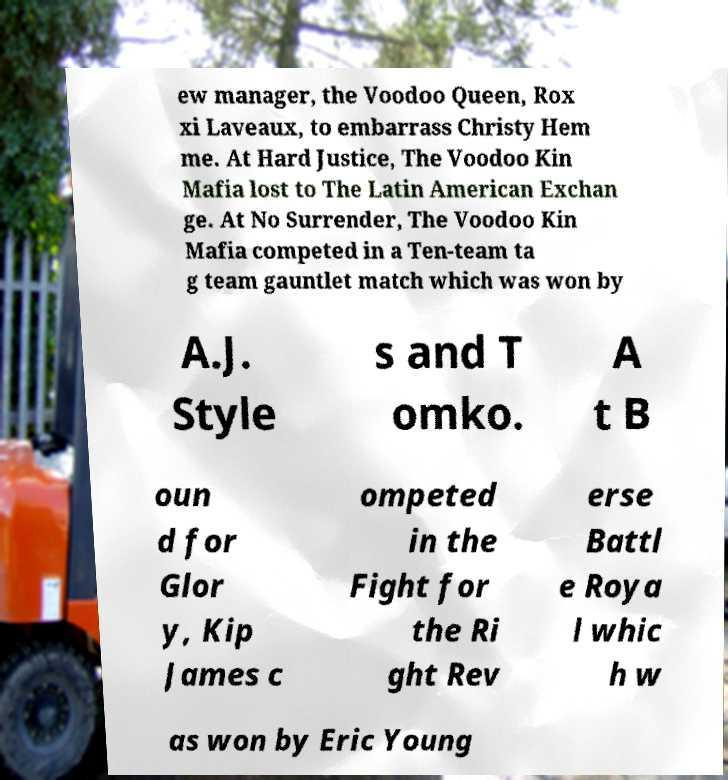Could you extract and type out the text from this image? ew manager, the Voodoo Queen, Rox xi Laveaux, to embarrass Christy Hem me. At Hard Justice, The Voodoo Kin Mafia lost to The Latin American Exchan ge. At No Surrender, The Voodoo Kin Mafia competed in a Ten-team ta g team gauntlet match which was won by A.J. Style s and T omko. A t B oun d for Glor y, Kip James c ompeted in the Fight for the Ri ght Rev erse Battl e Roya l whic h w as won by Eric Young 